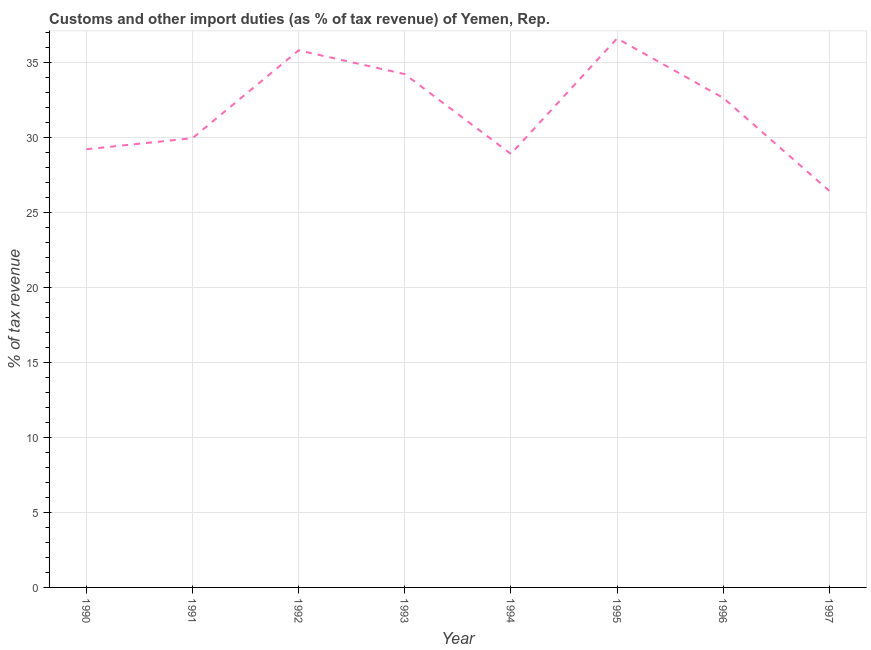What is the customs and other import duties in 1992?
Offer a very short reply. 35.81. Across all years, what is the maximum customs and other import duties?
Your answer should be compact. 36.6. Across all years, what is the minimum customs and other import duties?
Offer a terse response. 26.44. In which year was the customs and other import duties minimum?
Offer a terse response. 1997. What is the sum of the customs and other import duties?
Make the answer very short. 253.77. What is the difference between the customs and other import duties in 1993 and 1995?
Your answer should be compact. -2.38. What is the average customs and other import duties per year?
Provide a succinct answer. 31.72. What is the median customs and other import duties?
Provide a short and direct response. 31.29. In how many years, is the customs and other import duties greater than 10 %?
Keep it short and to the point. 8. Do a majority of the years between 1995 and 1991 (inclusive) have customs and other import duties greater than 23 %?
Offer a terse response. Yes. What is the ratio of the customs and other import duties in 1993 to that in 1994?
Ensure brevity in your answer.  1.18. Is the customs and other import duties in 1995 less than that in 1996?
Ensure brevity in your answer.  No. What is the difference between the highest and the second highest customs and other import duties?
Provide a short and direct response. 0.79. Is the sum of the customs and other import duties in 1993 and 1994 greater than the maximum customs and other import duties across all years?
Provide a short and direct response. Yes. What is the difference between the highest and the lowest customs and other import duties?
Your response must be concise. 10.16. How many lines are there?
Your response must be concise. 1. How many years are there in the graph?
Your answer should be very brief. 8. What is the difference between two consecutive major ticks on the Y-axis?
Give a very brief answer. 5. Are the values on the major ticks of Y-axis written in scientific E-notation?
Offer a terse response. No. Does the graph contain any zero values?
Provide a short and direct response. No. Does the graph contain grids?
Offer a terse response. Yes. What is the title of the graph?
Offer a terse response. Customs and other import duties (as % of tax revenue) of Yemen, Rep. What is the label or title of the X-axis?
Offer a terse response. Year. What is the label or title of the Y-axis?
Your answer should be very brief. % of tax revenue. What is the % of tax revenue in 1990?
Your answer should be very brief. 29.21. What is the % of tax revenue of 1991?
Your response must be concise. 29.95. What is the % of tax revenue of 1992?
Your answer should be compact. 35.81. What is the % of tax revenue of 1993?
Keep it short and to the point. 34.22. What is the % of tax revenue in 1994?
Your answer should be very brief. 28.9. What is the % of tax revenue of 1995?
Give a very brief answer. 36.6. What is the % of tax revenue in 1996?
Make the answer very short. 32.64. What is the % of tax revenue in 1997?
Make the answer very short. 26.44. What is the difference between the % of tax revenue in 1990 and 1991?
Keep it short and to the point. -0.74. What is the difference between the % of tax revenue in 1990 and 1992?
Offer a very short reply. -6.59. What is the difference between the % of tax revenue in 1990 and 1993?
Provide a succinct answer. -5.01. What is the difference between the % of tax revenue in 1990 and 1994?
Your response must be concise. 0.31. What is the difference between the % of tax revenue in 1990 and 1995?
Your response must be concise. -7.39. What is the difference between the % of tax revenue in 1990 and 1996?
Your response must be concise. -3.42. What is the difference between the % of tax revenue in 1990 and 1997?
Make the answer very short. 2.78. What is the difference between the % of tax revenue in 1991 and 1992?
Make the answer very short. -5.86. What is the difference between the % of tax revenue in 1991 and 1993?
Ensure brevity in your answer.  -4.27. What is the difference between the % of tax revenue in 1991 and 1994?
Provide a succinct answer. 1.05. What is the difference between the % of tax revenue in 1991 and 1995?
Keep it short and to the point. -6.65. What is the difference between the % of tax revenue in 1991 and 1996?
Provide a succinct answer. -2.69. What is the difference between the % of tax revenue in 1991 and 1997?
Offer a terse response. 3.51. What is the difference between the % of tax revenue in 1992 and 1993?
Provide a short and direct response. 1.58. What is the difference between the % of tax revenue in 1992 and 1994?
Give a very brief answer. 6.91. What is the difference between the % of tax revenue in 1992 and 1995?
Keep it short and to the point. -0.79. What is the difference between the % of tax revenue in 1992 and 1996?
Provide a short and direct response. 3.17. What is the difference between the % of tax revenue in 1992 and 1997?
Make the answer very short. 9.37. What is the difference between the % of tax revenue in 1993 and 1994?
Make the answer very short. 5.32. What is the difference between the % of tax revenue in 1993 and 1995?
Provide a short and direct response. -2.38. What is the difference between the % of tax revenue in 1993 and 1996?
Offer a terse response. 1.59. What is the difference between the % of tax revenue in 1993 and 1997?
Keep it short and to the point. 7.79. What is the difference between the % of tax revenue in 1994 and 1995?
Offer a terse response. -7.7. What is the difference between the % of tax revenue in 1994 and 1996?
Your response must be concise. -3.74. What is the difference between the % of tax revenue in 1994 and 1997?
Give a very brief answer. 2.46. What is the difference between the % of tax revenue in 1995 and 1996?
Make the answer very short. 3.96. What is the difference between the % of tax revenue in 1995 and 1997?
Offer a terse response. 10.16. What is the difference between the % of tax revenue in 1996 and 1997?
Give a very brief answer. 6.2. What is the ratio of the % of tax revenue in 1990 to that in 1991?
Your answer should be very brief. 0.97. What is the ratio of the % of tax revenue in 1990 to that in 1992?
Offer a terse response. 0.82. What is the ratio of the % of tax revenue in 1990 to that in 1993?
Provide a short and direct response. 0.85. What is the ratio of the % of tax revenue in 1990 to that in 1994?
Make the answer very short. 1.01. What is the ratio of the % of tax revenue in 1990 to that in 1995?
Make the answer very short. 0.8. What is the ratio of the % of tax revenue in 1990 to that in 1996?
Keep it short and to the point. 0.9. What is the ratio of the % of tax revenue in 1990 to that in 1997?
Offer a terse response. 1.1. What is the ratio of the % of tax revenue in 1991 to that in 1992?
Make the answer very short. 0.84. What is the ratio of the % of tax revenue in 1991 to that in 1993?
Provide a succinct answer. 0.88. What is the ratio of the % of tax revenue in 1991 to that in 1994?
Offer a terse response. 1.04. What is the ratio of the % of tax revenue in 1991 to that in 1995?
Keep it short and to the point. 0.82. What is the ratio of the % of tax revenue in 1991 to that in 1996?
Offer a terse response. 0.92. What is the ratio of the % of tax revenue in 1991 to that in 1997?
Give a very brief answer. 1.13. What is the ratio of the % of tax revenue in 1992 to that in 1993?
Make the answer very short. 1.05. What is the ratio of the % of tax revenue in 1992 to that in 1994?
Your answer should be compact. 1.24. What is the ratio of the % of tax revenue in 1992 to that in 1995?
Your answer should be very brief. 0.98. What is the ratio of the % of tax revenue in 1992 to that in 1996?
Your answer should be very brief. 1.1. What is the ratio of the % of tax revenue in 1992 to that in 1997?
Ensure brevity in your answer.  1.35. What is the ratio of the % of tax revenue in 1993 to that in 1994?
Your answer should be very brief. 1.18. What is the ratio of the % of tax revenue in 1993 to that in 1995?
Your response must be concise. 0.94. What is the ratio of the % of tax revenue in 1993 to that in 1996?
Make the answer very short. 1.05. What is the ratio of the % of tax revenue in 1993 to that in 1997?
Keep it short and to the point. 1.29. What is the ratio of the % of tax revenue in 1994 to that in 1995?
Your response must be concise. 0.79. What is the ratio of the % of tax revenue in 1994 to that in 1996?
Your response must be concise. 0.89. What is the ratio of the % of tax revenue in 1994 to that in 1997?
Give a very brief answer. 1.09. What is the ratio of the % of tax revenue in 1995 to that in 1996?
Provide a short and direct response. 1.12. What is the ratio of the % of tax revenue in 1995 to that in 1997?
Your response must be concise. 1.38. What is the ratio of the % of tax revenue in 1996 to that in 1997?
Your answer should be very brief. 1.24. 